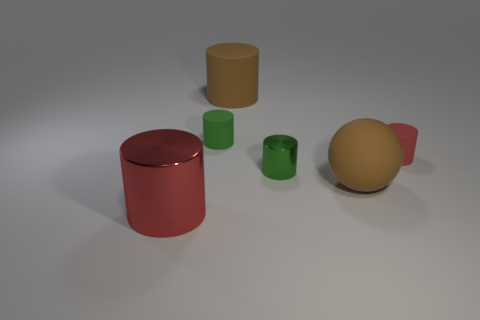Subtract all green cylinders. How many cylinders are left? 3 Subtract all red cylinders. How many cylinders are left? 3 Subtract all spheres. How many objects are left? 5 Subtract all green cubes. How many red cylinders are left? 2 Add 1 tiny metal cylinders. How many objects exist? 7 Subtract all yellow cylinders. Subtract all gray spheres. How many cylinders are left? 5 Subtract all small green matte things. Subtract all small matte cylinders. How many objects are left? 3 Add 2 brown rubber spheres. How many brown rubber spheres are left? 3 Add 1 green rubber objects. How many green rubber objects exist? 2 Subtract 0 blue spheres. How many objects are left? 6 